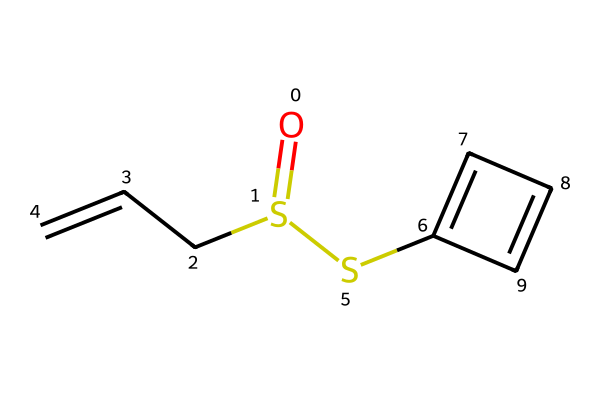What is the molecular formula of allicin? To find the molecular formula, we can analyze the SMILES representation. The structure includes carbon (C), hydrogen (H), oxygen (O), and sulfur (S). Counting the atoms gives: 6 carbon atoms, 10 hydrogen atoms, 2 sulfur atoms, and 1 oxygen atom, resulting in the formula C6H10O2S2.
Answer: C6H10O2S2 How many rings are present in the structure of allicin? The SMILES notation does not indicate the presence of any cyclic structures; it consists only of linear and branched chains. Therefore, there are no rings.
Answer: 0 Which element is represented by the 'O' in the SMILES? The 'O' in the SMILES represents an oxygen atom, which is a key component in the structure.
Answer: oxygen How many sulfur atoms are there in allicin? By examining the SMILES representation, we can see there are two occurrences of sulfur (S) within the structure.
Answer: 2 What type of compounds does allicin belong to? Allicin is classified as an organosulfur compound due to the presence of sulfur atoms within its structure that are directly bonded to carbon atoms.
Answer: organosulfur What functional groups are present in allicin? The SMILES representation shows that allicin contains both thioether (due to sulfur in the carbon chain) and thioester functional groups (due to the carbonyl connection with sulfur).
Answer: thioether and thioester What type of bonding is primarily found in allicin's structure? Analyzing the SMILES shows that allicin features covalent bonds between its atoms, primarily between carbon, sulfur, and oxygen.
Answer: covalent bonds 